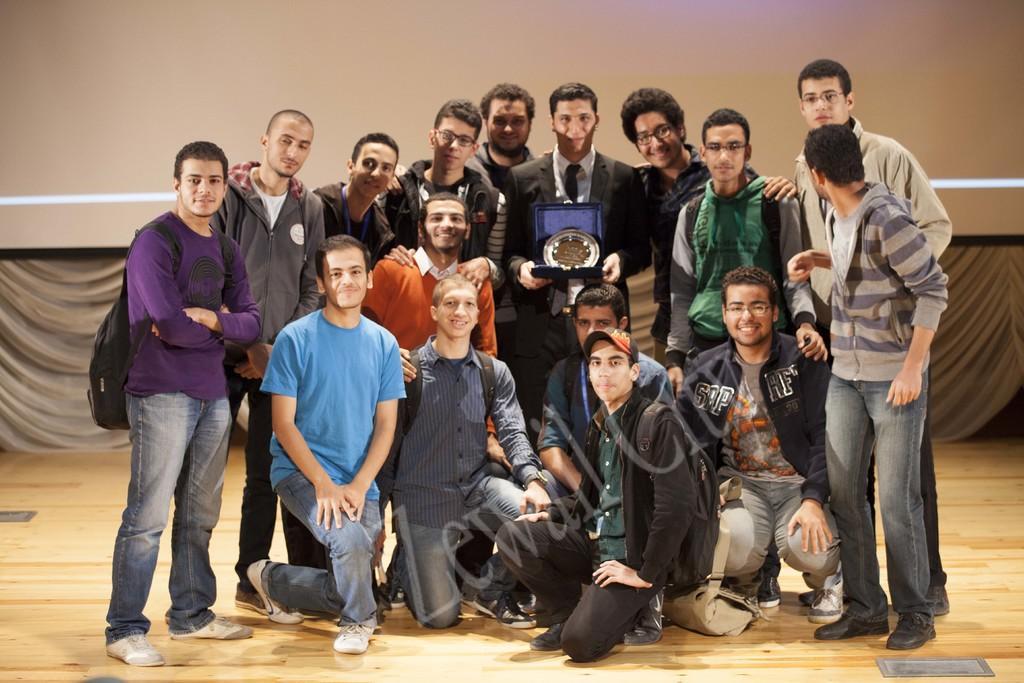How would you summarize this image in a sentence or two? In this image we can see group of people and one of them is holding a trophy with his hands. Here we can see floor. In the background there is a wall. 